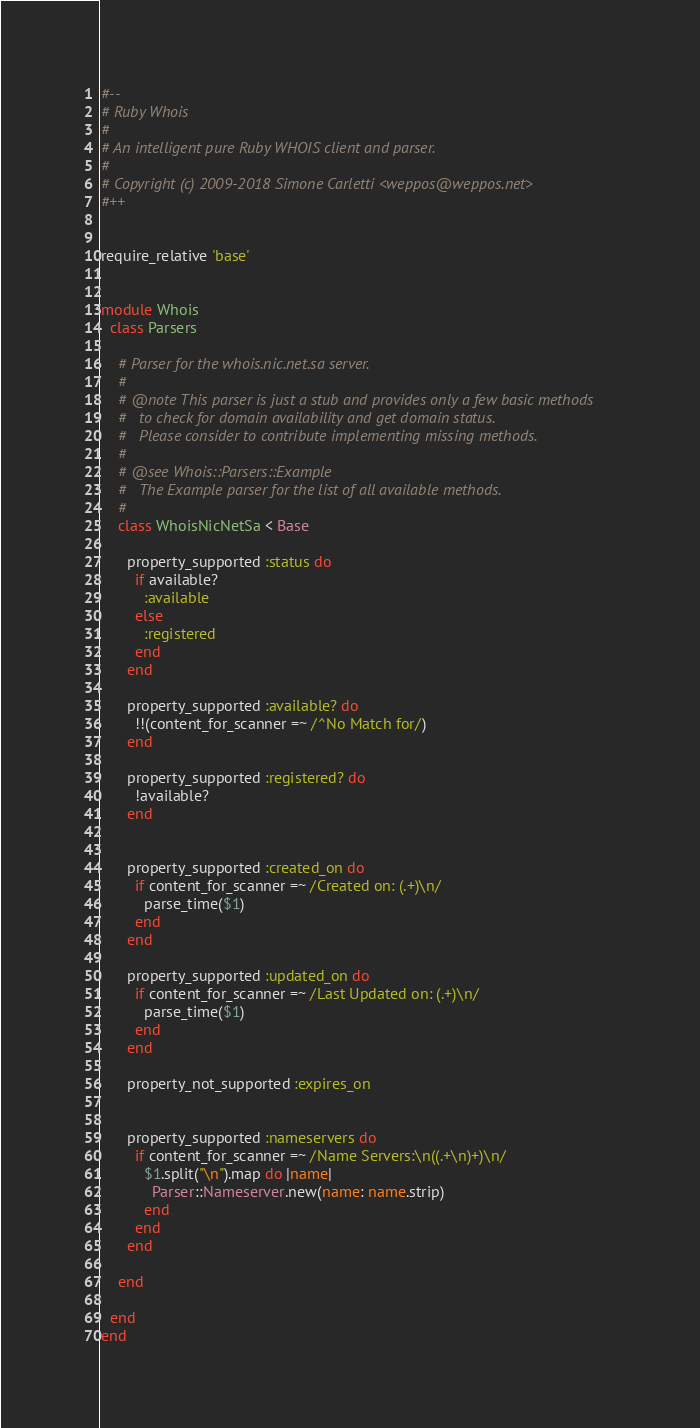<code> <loc_0><loc_0><loc_500><loc_500><_Ruby_>#--
# Ruby Whois
#
# An intelligent pure Ruby WHOIS client and parser.
#
# Copyright (c) 2009-2018 Simone Carletti <weppos@weppos.net>
#++


require_relative 'base'


module Whois
  class Parsers

    # Parser for the whois.nic.net.sa server.
    #
    # @note This parser is just a stub and provides only a few basic methods
    #   to check for domain availability and get domain status.
    #   Please consider to contribute implementing missing methods.
    #
    # @see Whois::Parsers::Example
    #   The Example parser for the list of all available methods.
    #
    class WhoisNicNetSa < Base

      property_supported :status do
        if available?
          :available
        else
          :registered
        end
      end

      property_supported :available? do
        !!(content_for_scanner =~ /^No Match for/)
      end

      property_supported :registered? do
        !available?
      end


      property_supported :created_on do
        if content_for_scanner =~ /Created on: (.+)\n/
          parse_time($1)
        end
      end

      property_supported :updated_on do
        if content_for_scanner =~ /Last Updated on: (.+)\n/
          parse_time($1)
        end
      end

      property_not_supported :expires_on


      property_supported :nameservers do
        if content_for_scanner =~ /Name Servers:\n((.+\n)+)\n/
          $1.split("\n").map do |name|
            Parser::Nameserver.new(name: name.strip)
          end
        end
      end

    end

  end
end
</code> 